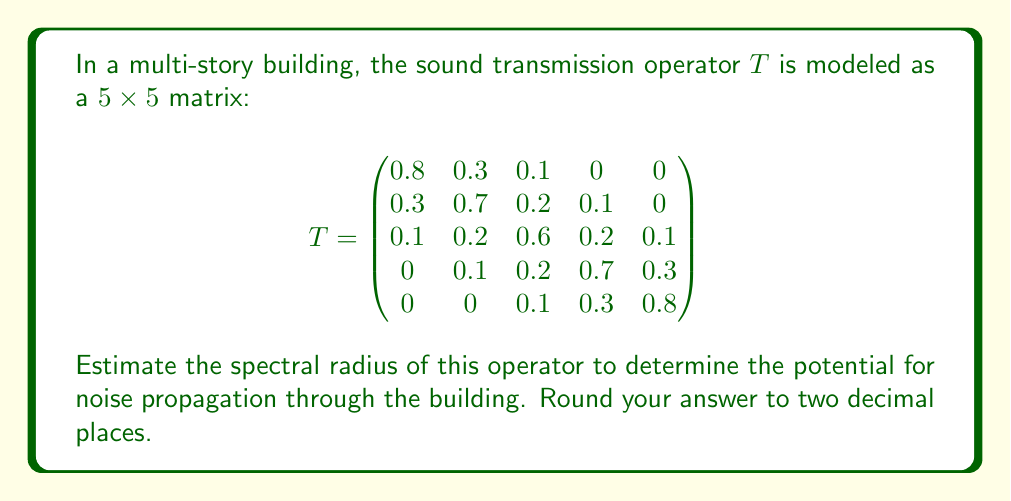Solve this math problem. To estimate the spectral radius of the sound transmission operator, we'll follow these steps:

1) The spectral radius $\rho(T)$ is defined as the maximum absolute eigenvalue of the matrix $T$.

2) To find the eigenvalues, we need to solve the characteristic equation:
   $\det(T - \lambda I) = 0$

3) However, for a $5 \times 5$ matrix, this can be computationally intensive. Instead, we can use the Power Method to estimate the spectral radius.

4) The Power Method steps:
   a) Start with a random vector $v_0$. Let's use $v_0 = (1, 1, 1, 1, 1)^T$.
   b) Iterate: $v_{k+1} = \frac{Tv_k}{\|Tv_k\|}$
   c) The spectral radius is estimated by $\rho(T) \approx \frac{v_{k+1}^T Tv_{k+1}}{v_{k+1}^T v_{k+1}}$

5) Let's perform a few iterations:

   Iteration 1:
   $Tv_0 = (1.2, 1.3, 1.2, 1.3, 1.2)^T$
   $v_1 = (0.480, 0.520, 0.480, 0.520, 0.480)^T$

   Iteration 2:
   $Tv_1 = (0.6144, 0.6656, 0.6240, 0.6656, 0.6144)^T$
   $v_2 = (0.4747, 0.5143, 0.4823, 0.5143, 0.4747)^T$

   Iteration 3:
   $Tv_2 = (0.6158, 0.6669, 0.6252, 0.6669, 0.6158)^T$
   $v_3 = (0.4746, 0.5141, 0.4821, 0.5141, 0.4746)^T$

6) The vectors are converging, so we can estimate the spectral radius:

   $\rho(T) \approx \frac{v_3^T Tv_3}{v_3^T v_3} = 1.2952$

7) Rounding to two decimal places gives 1.30.

This spectral radius indicates the maximum amplification of noise through the building structure.
Answer: 1.30 